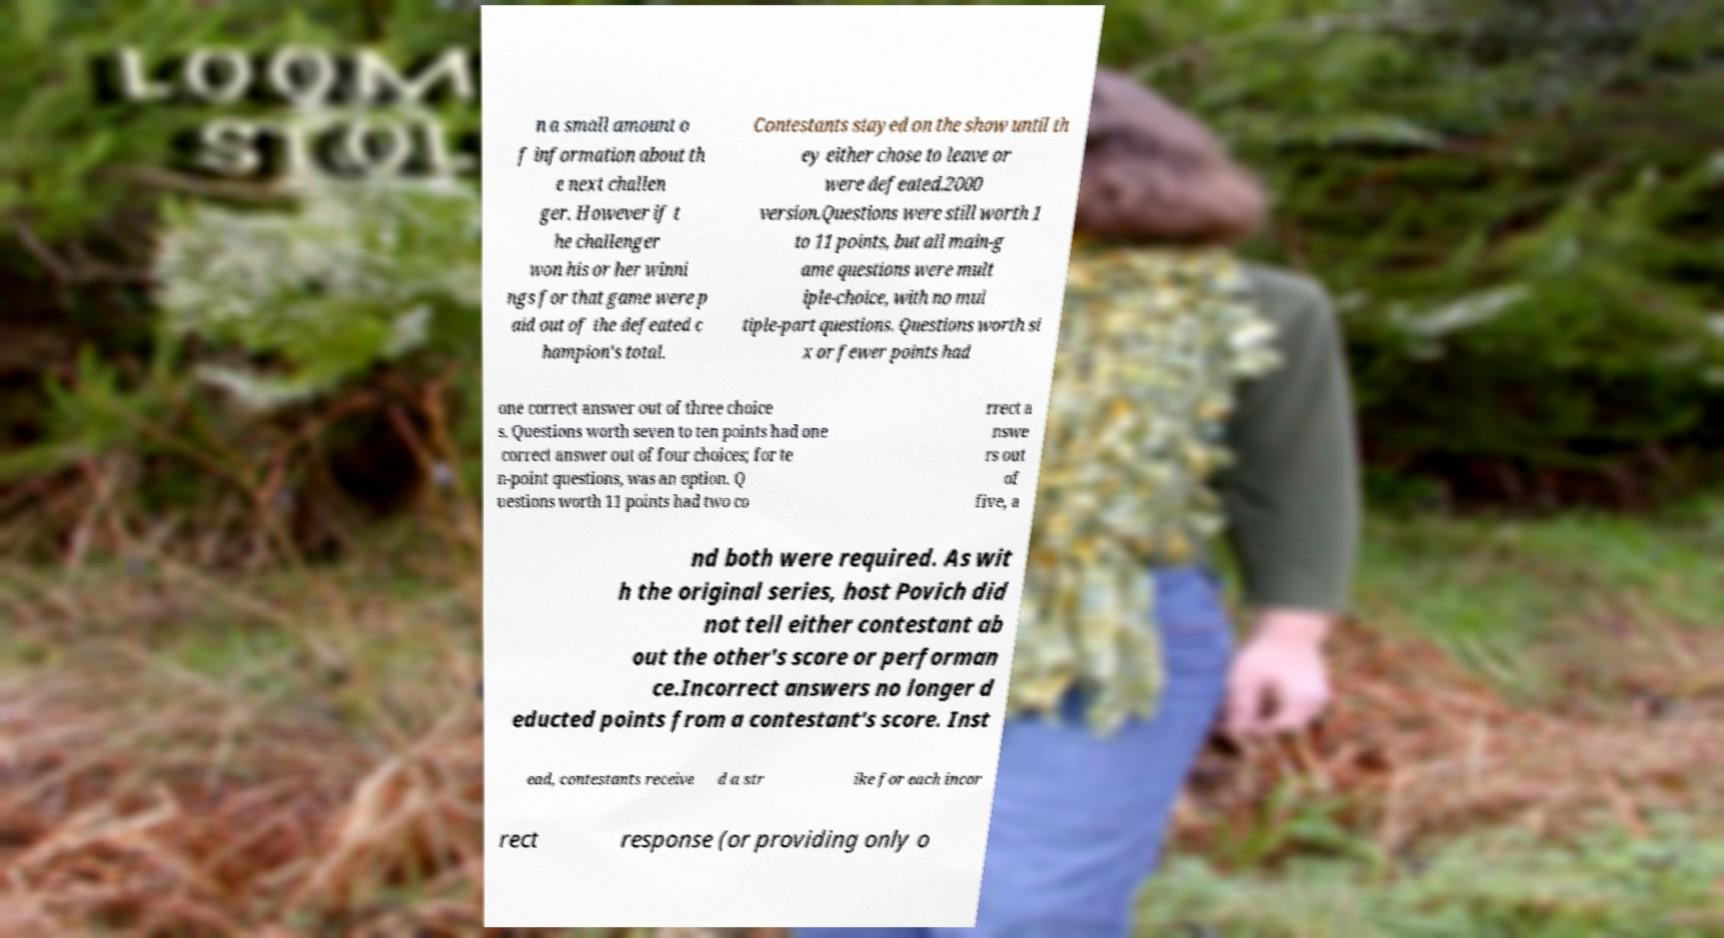Please identify and transcribe the text found in this image. n a small amount o f information about th e next challen ger. However if t he challenger won his or her winni ngs for that game were p aid out of the defeated c hampion's total. Contestants stayed on the show until th ey either chose to leave or were defeated.2000 version.Questions were still worth 1 to 11 points, but all main-g ame questions were mult iple-choice, with no mul tiple-part questions. Questions worth si x or fewer points had one correct answer out of three choice s. Questions worth seven to ten points had one correct answer out of four choices; for te n-point questions, was an option. Q uestions worth 11 points had two co rrect a nswe rs out of five, a nd both were required. As wit h the original series, host Povich did not tell either contestant ab out the other's score or performan ce.Incorrect answers no longer d educted points from a contestant's score. Inst ead, contestants receive d a str ike for each incor rect response (or providing only o 